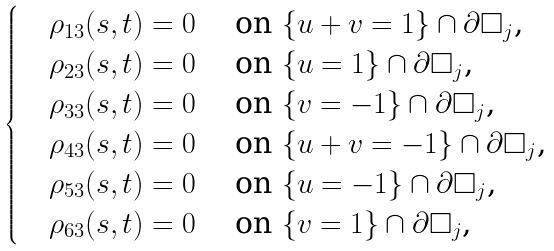<formula> <loc_0><loc_0><loc_500><loc_500>\begin{cases} & \rho _ { 1 3 } ( s , t ) = 0 \quad \text { on $\{u+v=1\}\cap \partial\square_{j}$,} \\ & \rho _ { 2 3 } ( s , t ) = 0 \quad \text { on $\{u=1\}\cap \partial\square_{j}$,} \\ & \rho _ { 3 3 } ( s , t ) = 0 \quad \text { on $\{v=-1\}\cap \partial\square_{j}$,} \\ & \rho _ { 4 3 } ( s , t ) = 0 \quad \text { on $\{u+v=-1\}\cap \partial\square_{j}$,} \\ & \rho _ { 5 3 } ( s , t ) = 0 \quad \text { on $\{u=-1\}\cap \partial\square_{j}$,} \\ & \rho _ { 6 3 } ( s , t ) = 0 \quad \text { on $\{v=1\}\cap \partial\square_{j}$,} \\ \end{cases}</formula> 